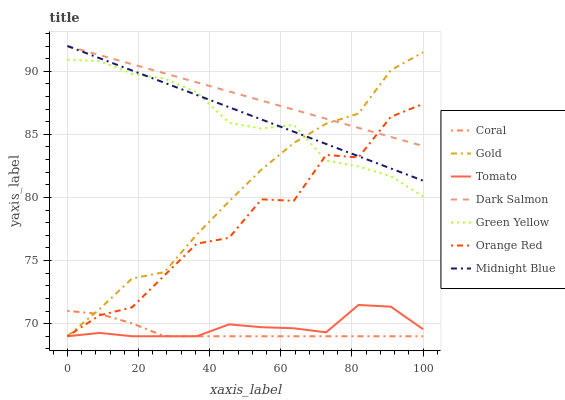Does Coral have the minimum area under the curve?
Answer yes or no. Yes. Does Dark Salmon have the maximum area under the curve?
Answer yes or no. Yes. Does Midnight Blue have the minimum area under the curve?
Answer yes or no. No. Does Midnight Blue have the maximum area under the curve?
Answer yes or no. No. Is Dark Salmon the smoothest?
Answer yes or no. Yes. Is Orange Red the roughest?
Answer yes or no. Yes. Is Midnight Blue the smoothest?
Answer yes or no. No. Is Midnight Blue the roughest?
Answer yes or no. No. Does Midnight Blue have the lowest value?
Answer yes or no. No. Does Dark Salmon have the highest value?
Answer yes or no. Yes. Does Gold have the highest value?
Answer yes or no. No. Is Coral less than Dark Salmon?
Answer yes or no. Yes. Is Dark Salmon greater than Tomato?
Answer yes or no. Yes. Does Coral intersect Dark Salmon?
Answer yes or no. No. 